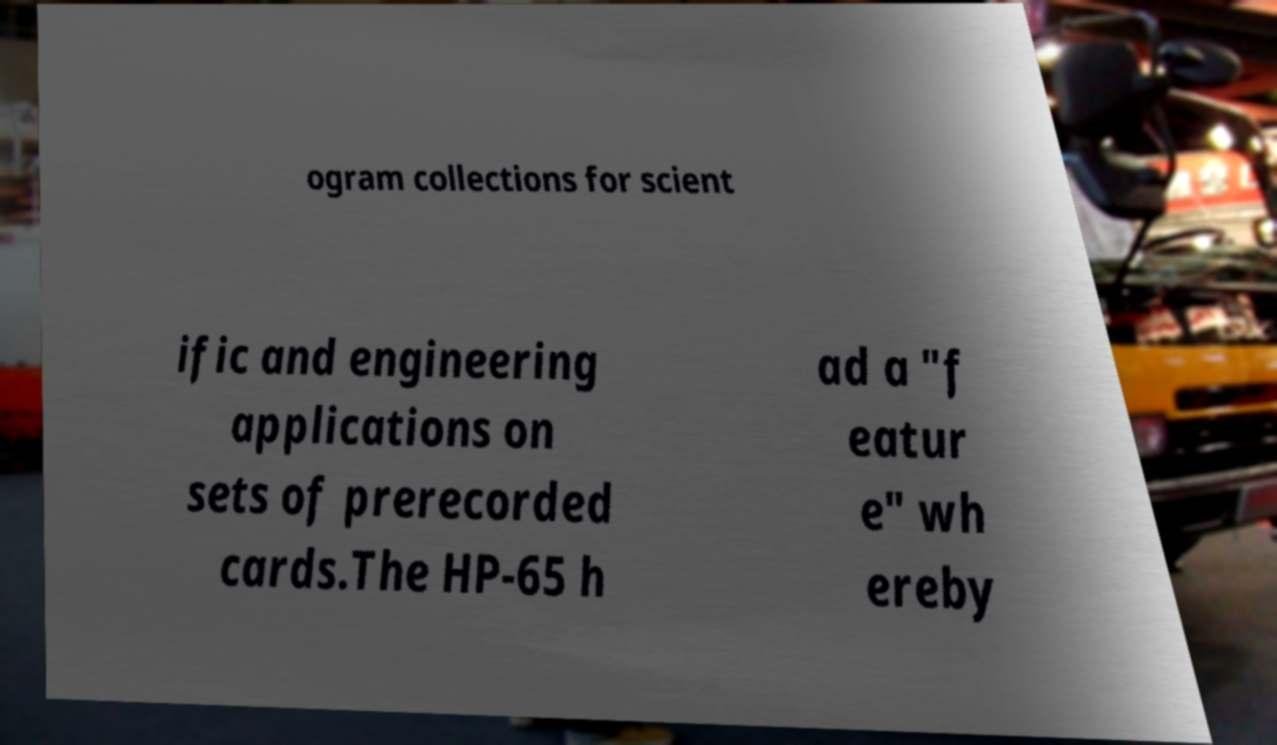Could you extract and type out the text from this image? ogram collections for scient ific and engineering applications on sets of prerecorded cards.The HP-65 h ad a "f eatur e" wh ereby 